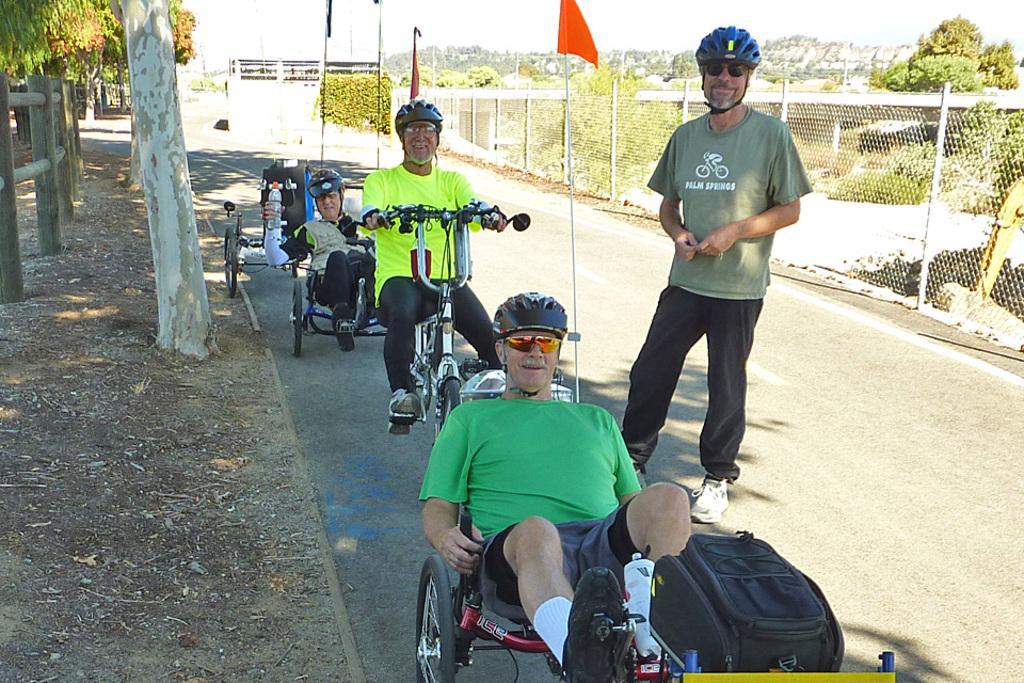Describe this image in one or two sentences. This is the picture on the road. There are four persons in the image, one person is standing and three persons are riding the vehicle. At the back there are flags and trees, at the right there is a fence, at the top there is a sky. 